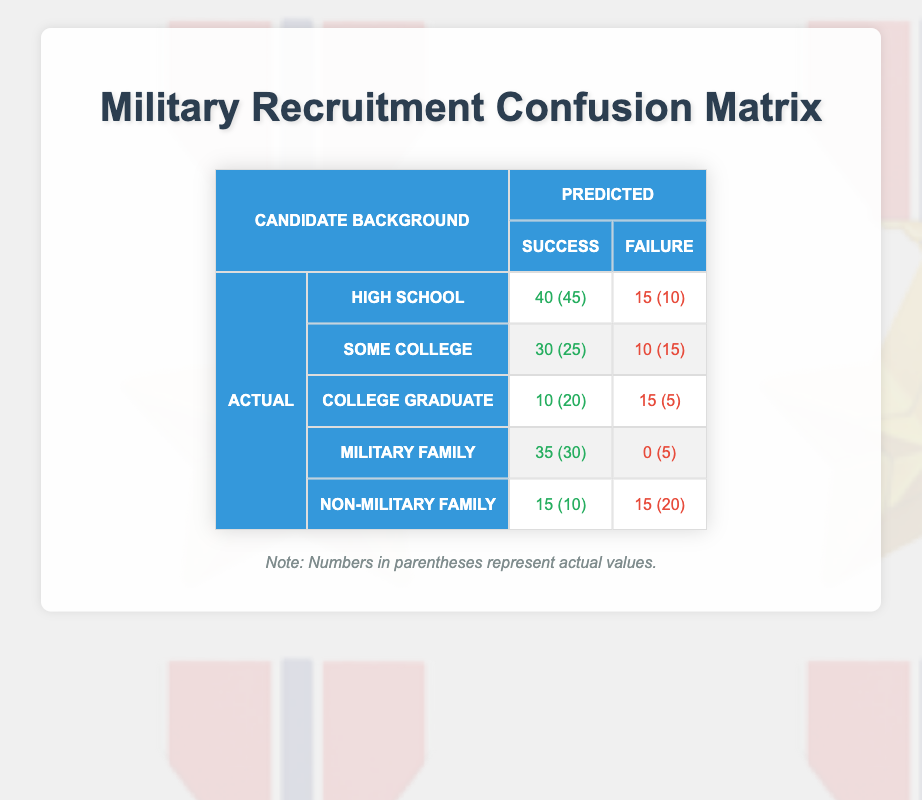What is the number of candidates predicted to be successful from high school backgrounds? The table shows that 40 candidates from high school backgrounds were predicted to be successful.
Answer: 40 How many candidates from military families were actually successful? According to the table, 30 candidates from military families were actually successful.
Answer: 30 What is the total number of candidates from college graduates predicted to fail? The table indicates that 15 candidates from college graduates were predicted to fail.
Answer: 15 Which background had the highest number of actual failures? By examining the "actual failure" row, non-military family had the highest actual failures with a count of 20.
Answer: Non-military family What is the difference between the actual number of successes and failures for candidates with some college backgrounds? The table shows 25 actual successes and 15 actual failures for some college backgrounds. The difference is 25 - 15 = 10.
Answer: 10 Are there more actual successes or failures among candidates from non-military families? For non-military families, there are 10 actual successes and 20 actual failures, indicating more failures.
Answer: Yes What is the overall total of candidates predicted to succeed across all backgrounds? To find this, sum up all the predicted successes: 40 (high school) + 30 (some college) + 10 (college graduates) + 35 (military family) + 15 (non-military family) = 130.
Answer: 130 How many candidates from high school backgrounds actually failed? The table shows that 10 candidates from high school backgrounds actually failed.
Answer: 10 What percentage of actual college graduates were predicted to succeed? There were 20 actual college graduates, with 10 predicted to succeed. The percentage is (10/20) * 100 = 50.
Answer: 50% What is the ratio of actual successes to actual failures for candidates from some college backgrounds? For some college backgrounds, there are 25 actual successes and 15 actual failures, giving a ratio of 25:15, which simplifies to 5:3.
Answer: 5:3 